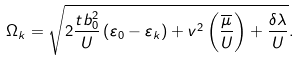<formula> <loc_0><loc_0><loc_500><loc_500>\Omega _ { k } = \sqrt { 2 \frac { t b _ { 0 } ^ { 2 } } { U } \left ( \varepsilon _ { 0 } - \varepsilon _ { k } \right ) + v ^ { 2 } \left ( \frac { \overline { \mu } } { U } \right ) + \frac { \delta \lambda } { U } } .</formula> 